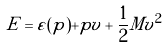<formula> <loc_0><loc_0><loc_500><loc_500>E = \varepsilon ( p ) + p v + \frac { 1 } { 2 } M v ^ { 2 }</formula> 